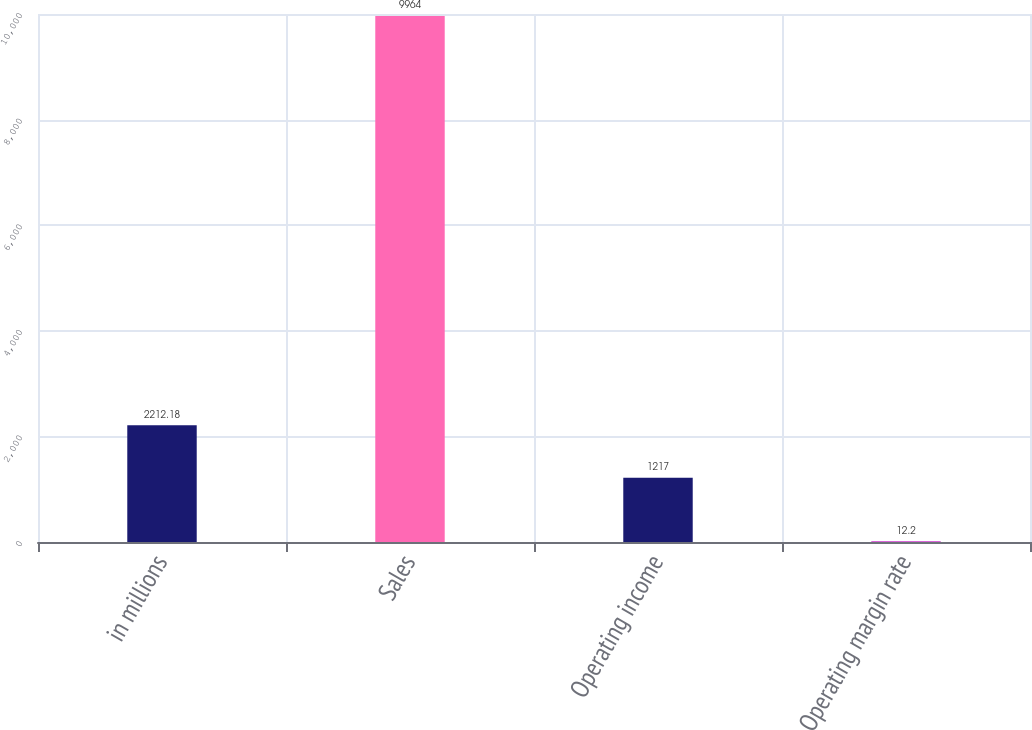Convert chart. <chart><loc_0><loc_0><loc_500><loc_500><bar_chart><fcel>in millions<fcel>Sales<fcel>Operating income<fcel>Operating margin rate<nl><fcel>2212.18<fcel>9964<fcel>1217<fcel>12.2<nl></chart> 